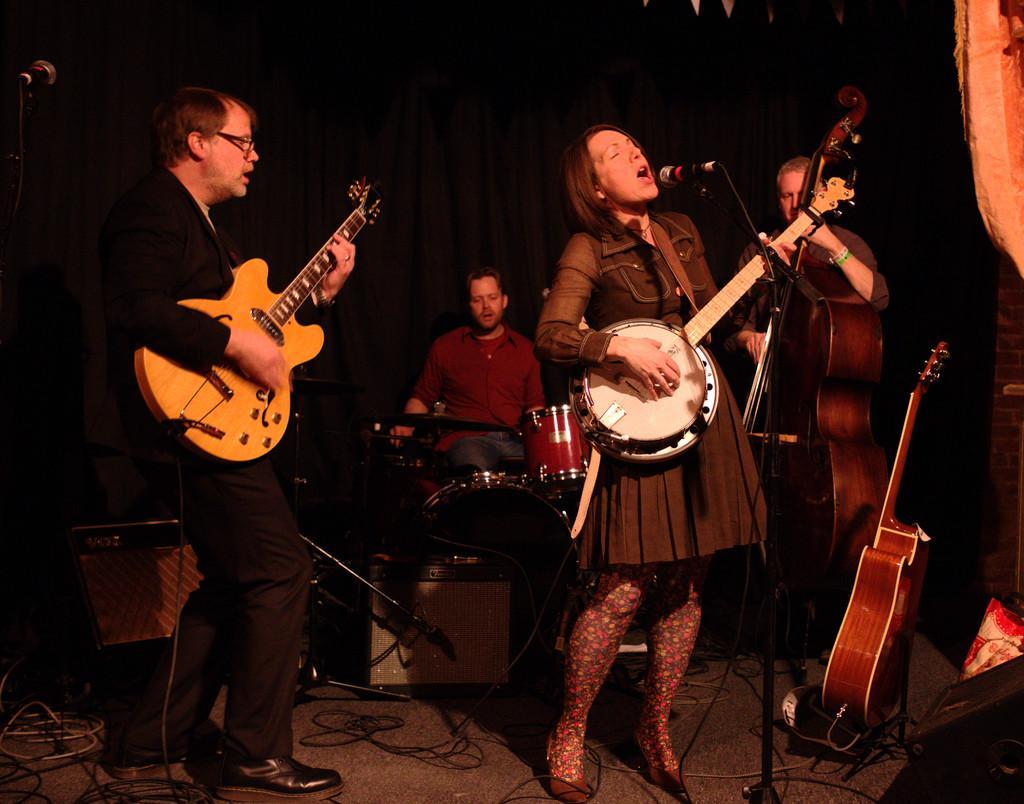Can you describe this image briefly? In this image we can see a woman is singing and playing the guitar, and in front here is the microphone and stand, and at back a person is standing and playing the guitar, and at back a person is sitting and playing the drums. 